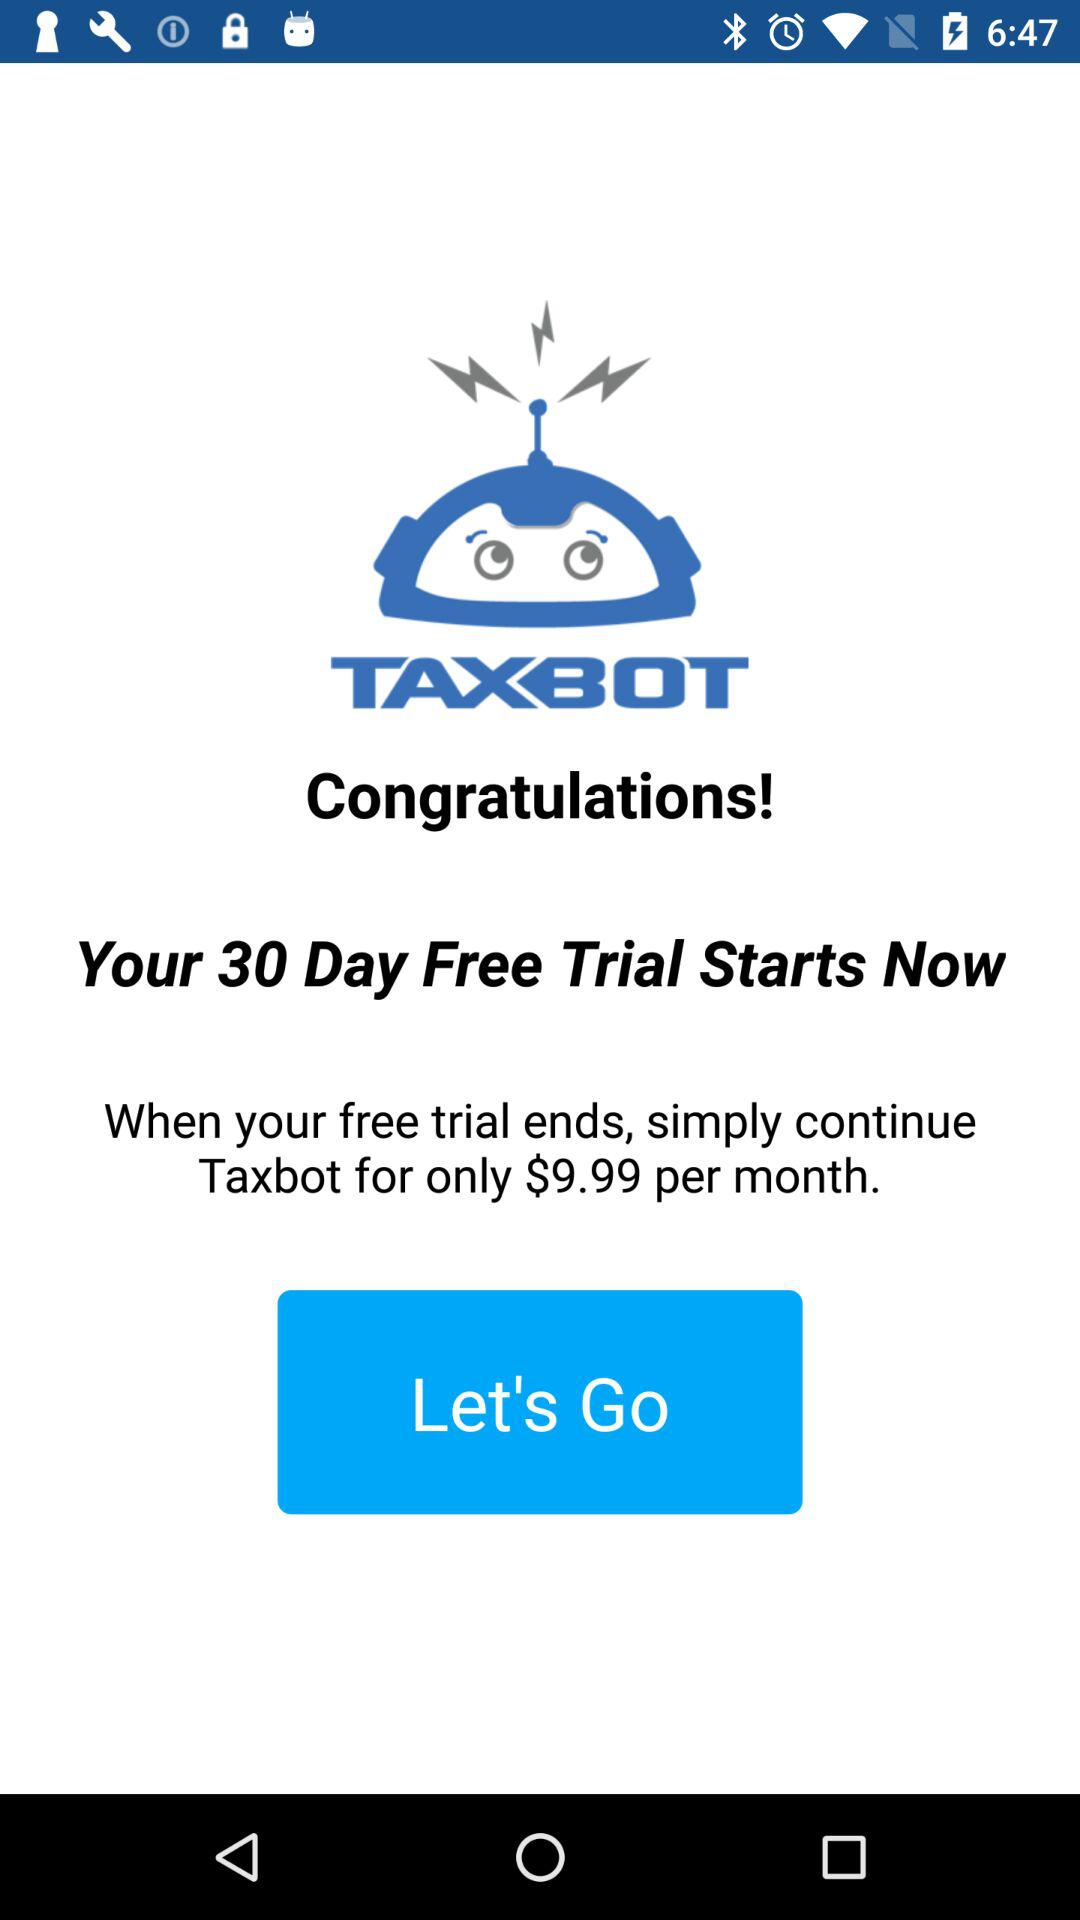What's the number of days of free trial? There are 30 days of free trial. 